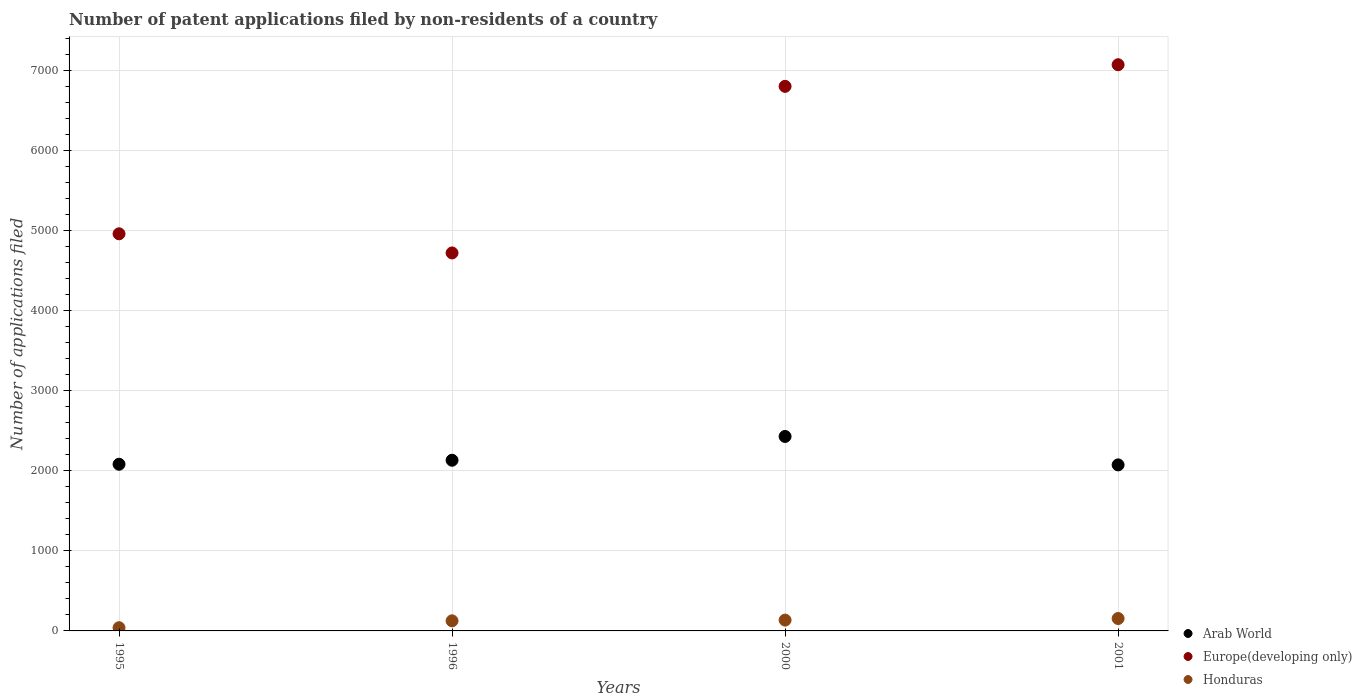What is the number of applications filed in Arab World in 2001?
Your answer should be compact. 2073. Across all years, what is the maximum number of applications filed in Arab World?
Provide a short and direct response. 2428. Across all years, what is the minimum number of applications filed in Arab World?
Ensure brevity in your answer.  2073. What is the total number of applications filed in Europe(developing only) in the graph?
Ensure brevity in your answer.  2.35e+04. What is the difference between the number of applications filed in Europe(developing only) in 1995 and that in 2001?
Offer a terse response. -2111. What is the difference between the number of applications filed in Arab World in 2001 and the number of applications filed in Honduras in 2000?
Ensure brevity in your answer.  1938. What is the average number of applications filed in Europe(developing only) per year?
Ensure brevity in your answer.  5886.25. In the year 1996, what is the difference between the number of applications filed in Europe(developing only) and number of applications filed in Arab World?
Your answer should be compact. 2588. In how many years, is the number of applications filed in Europe(developing only) greater than 1800?
Your answer should be very brief. 4. What is the ratio of the number of applications filed in Arab World in 1996 to that in 2000?
Give a very brief answer. 0.88. What is the difference between the highest and the second highest number of applications filed in Honduras?
Provide a succinct answer. 20. What is the difference between the highest and the lowest number of applications filed in Europe(developing only)?
Offer a very short reply. 2350. In how many years, is the number of applications filed in Europe(developing only) greater than the average number of applications filed in Europe(developing only) taken over all years?
Ensure brevity in your answer.  2. Is the sum of the number of applications filed in Europe(developing only) in 1995 and 2000 greater than the maximum number of applications filed in Honduras across all years?
Your response must be concise. Yes. Is it the case that in every year, the sum of the number of applications filed in Arab World and number of applications filed in Honduras  is greater than the number of applications filed in Europe(developing only)?
Give a very brief answer. No. Is the number of applications filed in Europe(developing only) strictly greater than the number of applications filed in Honduras over the years?
Give a very brief answer. Yes. Is the number of applications filed in Honduras strictly less than the number of applications filed in Arab World over the years?
Your answer should be very brief. Yes. How many years are there in the graph?
Your response must be concise. 4. What is the difference between two consecutive major ticks on the Y-axis?
Your response must be concise. 1000. Does the graph contain any zero values?
Make the answer very short. No. How many legend labels are there?
Keep it short and to the point. 3. How are the legend labels stacked?
Make the answer very short. Vertical. What is the title of the graph?
Your answer should be compact. Number of patent applications filed by non-residents of a country. Does "Iran" appear as one of the legend labels in the graph?
Ensure brevity in your answer.  No. What is the label or title of the Y-axis?
Keep it short and to the point. Number of applications filed. What is the Number of applications filed in Arab World in 1995?
Ensure brevity in your answer.  2081. What is the Number of applications filed in Europe(developing only) in 1995?
Your answer should be very brief. 4958. What is the Number of applications filed in Arab World in 1996?
Provide a succinct answer. 2131. What is the Number of applications filed of Europe(developing only) in 1996?
Offer a very short reply. 4719. What is the Number of applications filed in Honduras in 1996?
Make the answer very short. 126. What is the Number of applications filed in Arab World in 2000?
Offer a very short reply. 2428. What is the Number of applications filed of Europe(developing only) in 2000?
Offer a very short reply. 6799. What is the Number of applications filed of Honduras in 2000?
Offer a terse response. 135. What is the Number of applications filed in Arab World in 2001?
Ensure brevity in your answer.  2073. What is the Number of applications filed in Europe(developing only) in 2001?
Make the answer very short. 7069. What is the Number of applications filed of Honduras in 2001?
Ensure brevity in your answer.  155. Across all years, what is the maximum Number of applications filed of Arab World?
Make the answer very short. 2428. Across all years, what is the maximum Number of applications filed of Europe(developing only)?
Make the answer very short. 7069. Across all years, what is the maximum Number of applications filed of Honduras?
Your response must be concise. 155. Across all years, what is the minimum Number of applications filed of Arab World?
Provide a short and direct response. 2073. Across all years, what is the minimum Number of applications filed in Europe(developing only)?
Give a very brief answer. 4719. What is the total Number of applications filed of Arab World in the graph?
Offer a very short reply. 8713. What is the total Number of applications filed in Europe(developing only) in the graph?
Offer a terse response. 2.35e+04. What is the total Number of applications filed in Honduras in the graph?
Your response must be concise. 456. What is the difference between the Number of applications filed in Arab World in 1995 and that in 1996?
Provide a short and direct response. -50. What is the difference between the Number of applications filed in Europe(developing only) in 1995 and that in 1996?
Your answer should be very brief. 239. What is the difference between the Number of applications filed of Honduras in 1995 and that in 1996?
Your response must be concise. -86. What is the difference between the Number of applications filed of Arab World in 1995 and that in 2000?
Provide a succinct answer. -347. What is the difference between the Number of applications filed of Europe(developing only) in 1995 and that in 2000?
Offer a terse response. -1841. What is the difference between the Number of applications filed of Honduras in 1995 and that in 2000?
Give a very brief answer. -95. What is the difference between the Number of applications filed in Arab World in 1995 and that in 2001?
Provide a succinct answer. 8. What is the difference between the Number of applications filed in Europe(developing only) in 1995 and that in 2001?
Offer a terse response. -2111. What is the difference between the Number of applications filed of Honduras in 1995 and that in 2001?
Offer a terse response. -115. What is the difference between the Number of applications filed in Arab World in 1996 and that in 2000?
Ensure brevity in your answer.  -297. What is the difference between the Number of applications filed of Europe(developing only) in 1996 and that in 2000?
Ensure brevity in your answer.  -2080. What is the difference between the Number of applications filed in Honduras in 1996 and that in 2000?
Your answer should be compact. -9. What is the difference between the Number of applications filed of Europe(developing only) in 1996 and that in 2001?
Your answer should be compact. -2350. What is the difference between the Number of applications filed of Honduras in 1996 and that in 2001?
Make the answer very short. -29. What is the difference between the Number of applications filed of Arab World in 2000 and that in 2001?
Provide a short and direct response. 355. What is the difference between the Number of applications filed of Europe(developing only) in 2000 and that in 2001?
Keep it short and to the point. -270. What is the difference between the Number of applications filed of Arab World in 1995 and the Number of applications filed of Europe(developing only) in 1996?
Provide a short and direct response. -2638. What is the difference between the Number of applications filed of Arab World in 1995 and the Number of applications filed of Honduras in 1996?
Ensure brevity in your answer.  1955. What is the difference between the Number of applications filed of Europe(developing only) in 1995 and the Number of applications filed of Honduras in 1996?
Offer a very short reply. 4832. What is the difference between the Number of applications filed of Arab World in 1995 and the Number of applications filed of Europe(developing only) in 2000?
Ensure brevity in your answer.  -4718. What is the difference between the Number of applications filed in Arab World in 1995 and the Number of applications filed in Honduras in 2000?
Give a very brief answer. 1946. What is the difference between the Number of applications filed in Europe(developing only) in 1995 and the Number of applications filed in Honduras in 2000?
Give a very brief answer. 4823. What is the difference between the Number of applications filed of Arab World in 1995 and the Number of applications filed of Europe(developing only) in 2001?
Provide a short and direct response. -4988. What is the difference between the Number of applications filed of Arab World in 1995 and the Number of applications filed of Honduras in 2001?
Your response must be concise. 1926. What is the difference between the Number of applications filed of Europe(developing only) in 1995 and the Number of applications filed of Honduras in 2001?
Give a very brief answer. 4803. What is the difference between the Number of applications filed in Arab World in 1996 and the Number of applications filed in Europe(developing only) in 2000?
Make the answer very short. -4668. What is the difference between the Number of applications filed of Arab World in 1996 and the Number of applications filed of Honduras in 2000?
Your answer should be compact. 1996. What is the difference between the Number of applications filed of Europe(developing only) in 1996 and the Number of applications filed of Honduras in 2000?
Your answer should be very brief. 4584. What is the difference between the Number of applications filed of Arab World in 1996 and the Number of applications filed of Europe(developing only) in 2001?
Your answer should be very brief. -4938. What is the difference between the Number of applications filed of Arab World in 1996 and the Number of applications filed of Honduras in 2001?
Your response must be concise. 1976. What is the difference between the Number of applications filed in Europe(developing only) in 1996 and the Number of applications filed in Honduras in 2001?
Offer a terse response. 4564. What is the difference between the Number of applications filed in Arab World in 2000 and the Number of applications filed in Europe(developing only) in 2001?
Your response must be concise. -4641. What is the difference between the Number of applications filed in Arab World in 2000 and the Number of applications filed in Honduras in 2001?
Offer a terse response. 2273. What is the difference between the Number of applications filed of Europe(developing only) in 2000 and the Number of applications filed of Honduras in 2001?
Provide a short and direct response. 6644. What is the average Number of applications filed of Arab World per year?
Provide a succinct answer. 2178.25. What is the average Number of applications filed in Europe(developing only) per year?
Give a very brief answer. 5886.25. What is the average Number of applications filed of Honduras per year?
Your answer should be very brief. 114. In the year 1995, what is the difference between the Number of applications filed of Arab World and Number of applications filed of Europe(developing only)?
Your answer should be very brief. -2877. In the year 1995, what is the difference between the Number of applications filed in Arab World and Number of applications filed in Honduras?
Provide a succinct answer. 2041. In the year 1995, what is the difference between the Number of applications filed of Europe(developing only) and Number of applications filed of Honduras?
Provide a short and direct response. 4918. In the year 1996, what is the difference between the Number of applications filed in Arab World and Number of applications filed in Europe(developing only)?
Your answer should be very brief. -2588. In the year 1996, what is the difference between the Number of applications filed in Arab World and Number of applications filed in Honduras?
Give a very brief answer. 2005. In the year 1996, what is the difference between the Number of applications filed of Europe(developing only) and Number of applications filed of Honduras?
Offer a terse response. 4593. In the year 2000, what is the difference between the Number of applications filed of Arab World and Number of applications filed of Europe(developing only)?
Provide a short and direct response. -4371. In the year 2000, what is the difference between the Number of applications filed of Arab World and Number of applications filed of Honduras?
Make the answer very short. 2293. In the year 2000, what is the difference between the Number of applications filed of Europe(developing only) and Number of applications filed of Honduras?
Your answer should be very brief. 6664. In the year 2001, what is the difference between the Number of applications filed in Arab World and Number of applications filed in Europe(developing only)?
Provide a succinct answer. -4996. In the year 2001, what is the difference between the Number of applications filed in Arab World and Number of applications filed in Honduras?
Provide a succinct answer. 1918. In the year 2001, what is the difference between the Number of applications filed in Europe(developing only) and Number of applications filed in Honduras?
Make the answer very short. 6914. What is the ratio of the Number of applications filed in Arab World in 1995 to that in 1996?
Keep it short and to the point. 0.98. What is the ratio of the Number of applications filed in Europe(developing only) in 1995 to that in 1996?
Give a very brief answer. 1.05. What is the ratio of the Number of applications filed in Honduras in 1995 to that in 1996?
Your response must be concise. 0.32. What is the ratio of the Number of applications filed of Arab World in 1995 to that in 2000?
Ensure brevity in your answer.  0.86. What is the ratio of the Number of applications filed in Europe(developing only) in 1995 to that in 2000?
Provide a short and direct response. 0.73. What is the ratio of the Number of applications filed in Honduras in 1995 to that in 2000?
Offer a terse response. 0.3. What is the ratio of the Number of applications filed of Arab World in 1995 to that in 2001?
Offer a very short reply. 1. What is the ratio of the Number of applications filed in Europe(developing only) in 1995 to that in 2001?
Your answer should be compact. 0.7. What is the ratio of the Number of applications filed in Honduras in 1995 to that in 2001?
Keep it short and to the point. 0.26. What is the ratio of the Number of applications filed of Arab World in 1996 to that in 2000?
Provide a short and direct response. 0.88. What is the ratio of the Number of applications filed in Europe(developing only) in 1996 to that in 2000?
Provide a succinct answer. 0.69. What is the ratio of the Number of applications filed in Honduras in 1996 to that in 2000?
Make the answer very short. 0.93. What is the ratio of the Number of applications filed in Arab World in 1996 to that in 2001?
Your answer should be very brief. 1.03. What is the ratio of the Number of applications filed of Europe(developing only) in 1996 to that in 2001?
Your response must be concise. 0.67. What is the ratio of the Number of applications filed in Honduras in 1996 to that in 2001?
Your response must be concise. 0.81. What is the ratio of the Number of applications filed of Arab World in 2000 to that in 2001?
Your answer should be very brief. 1.17. What is the ratio of the Number of applications filed in Europe(developing only) in 2000 to that in 2001?
Your response must be concise. 0.96. What is the ratio of the Number of applications filed in Honduras in 2000 to that in 2001?
Your answer should be compact. 0.87. What is the difference between the highest and the second highest Number of applications filed in Arab World?
Offer a very short reply. 297. What is the difference between the highest and the second highest Number of applications filed in Europe(developing only)?
Make the answer very short. 270. What is the difference between the highest and the lowest Number of applications filed in Arab World?
Ensure brevity in your answer.  355. What is the difference between the highest and the lowest Number of applications filed of Europe(developing only)?
Your answer should be compact. 2350. What is the difference between the highest and the lowest Number of applications filed of Honduras?
Give a very brief answer. 115. 